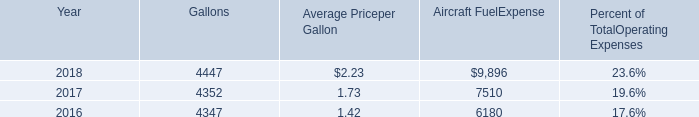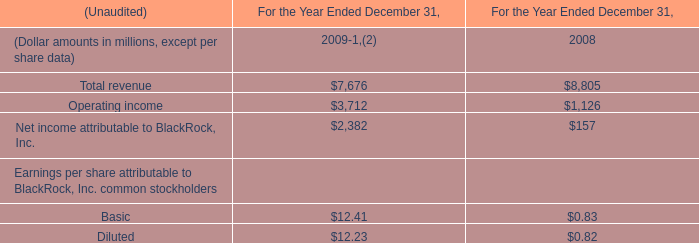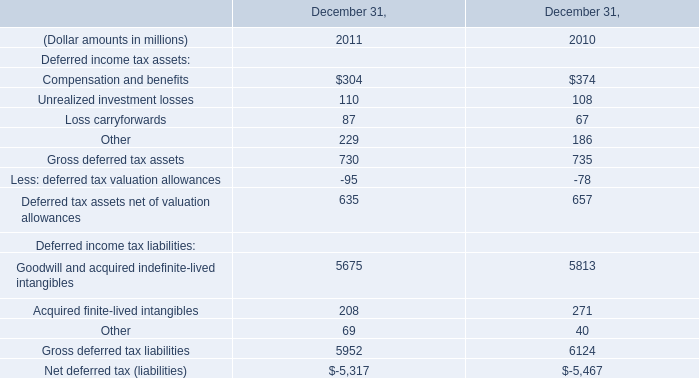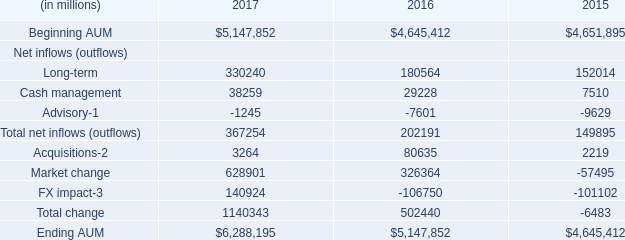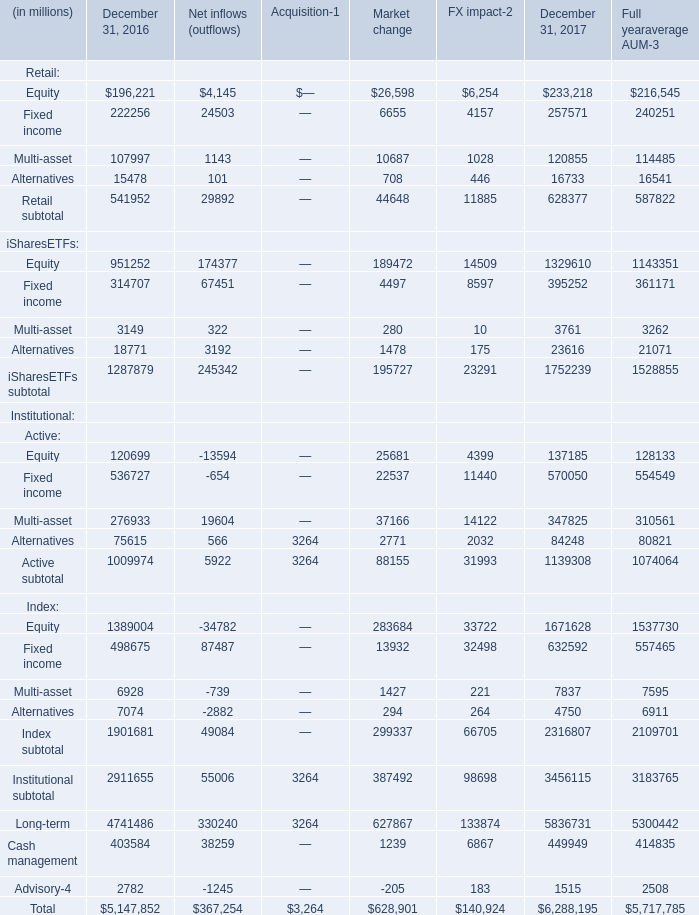What's the average of Total change in 2017? (in million) 
Computations: (1140343 / 3)
Answer: 380114.33333. 